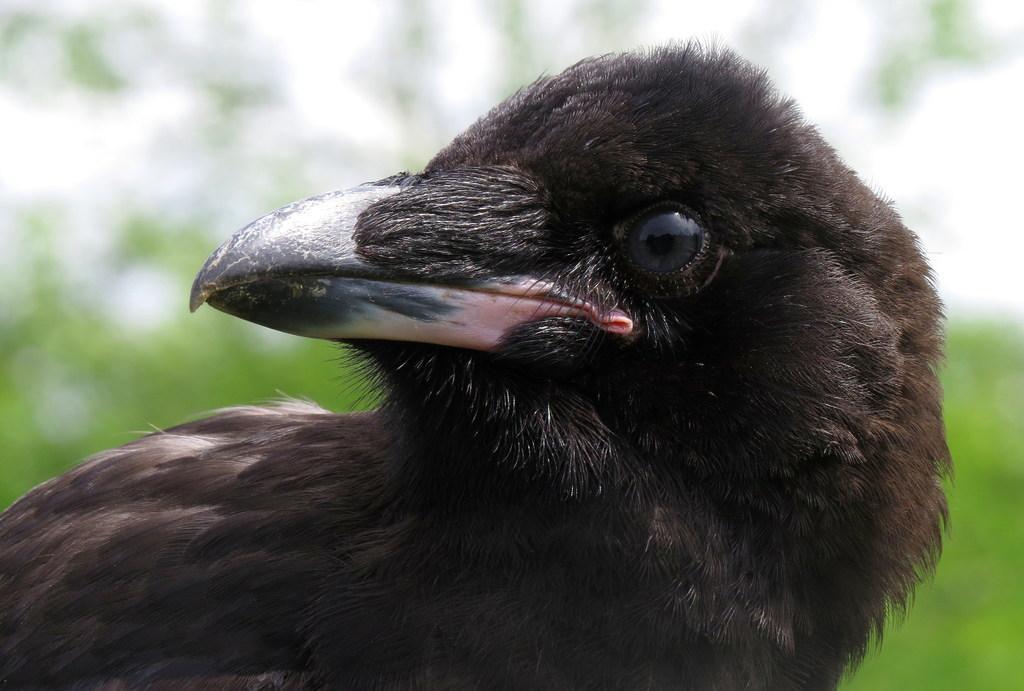Could you give a brief overview of what you see in this image? In this image we can see a bird and the background is blurred. 